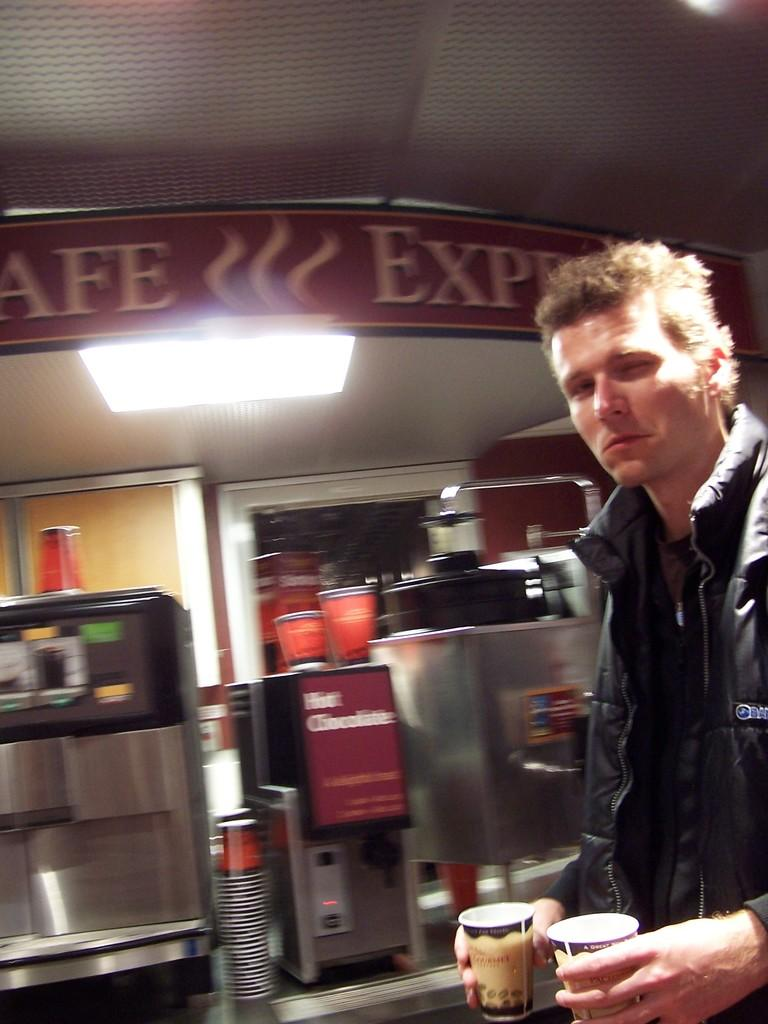<image>
Offer a succinct explanation of the picture presented. A man is walking in front of a hot chocolate machine. 